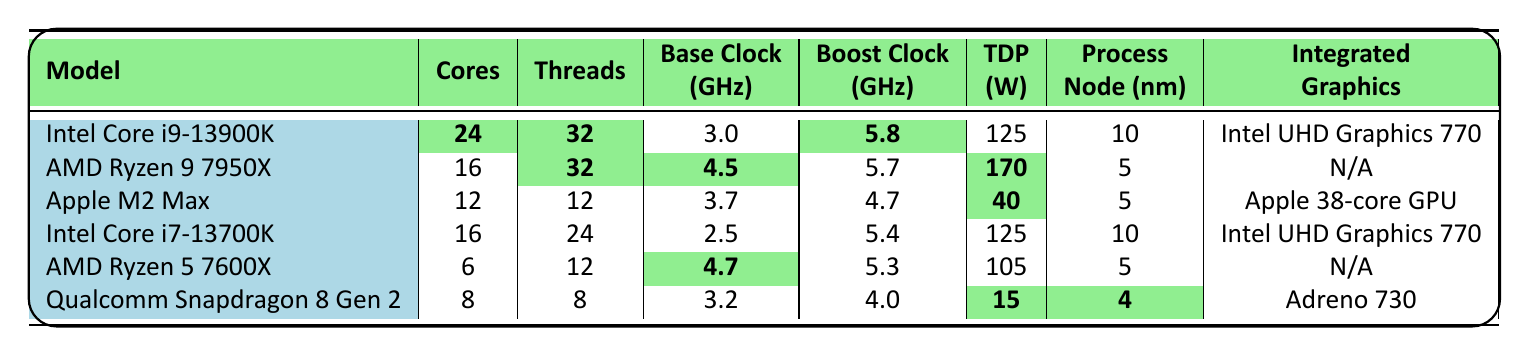What is the TDP of the AMD Ryzen 9 7950X? The TDP of the AMD Ryzen 9 7950X is listed directly in the table as 170 watts.
Answer: 170 W Which CPU has the highest base clock speed? By comparing the base clock speeds in the table, the AMD Ryzen 5 7600X has the highest base clock speed at 4.7 GHz.
Answer: 4.7 GHz How many threads does the Intel Core i7-13700K have? The number of threads for the Intel Core i7-13700K is clearly stated in the table as 24.
Answer: 24 What is the difference in TDP between the Intel Core i9-13900K and the Qualcomm Snapdragon 8 Gen 2? The TDP of the Intel Core i9-13900K is 125 W, and the TDP of the Qualcomm Snapdragon 8 Gen 2 is 15 W. The difference is 125 - 15 = 110 W.
Answer: 110 W Which CPU has the lowest number of cores? The table shows that the AMD Ryzen 5 7600X has the lowest number of cores, which is 6.
Answer: 6 What is the average base clock speed of the CPUs listed in the table? The base clock speeds are 3.0, 4.5, 3.7, 2.5, 4.7, and 3.2 GHz. Adding these gives a total of 21.6 GHz, and dividing by 6 (the number of CPUs) yields an average of 3.6 GHz.
Answer: 3.6 GHz True or False: The Apple M2 Max has more threads than the AMD Ryzen 5 7600X. The table indicates that the Apple M2 Max has 12 threads, while the AMD Ryzen 5 7600X has 12 threads as well. Therefore, the statement is false as they have equal threads.
Answer: False Which CPU has the highest boost clock speed? According to the table, the Intel Core i9-13900K has the highest boost clock speed at 5.8 GHz.
Answer: 5.8 GHz If you combine the cores of Intel Core i9-13900K and AMD Ryzen 9 7950X, how many cores will you have in total? The Intel Core i9-13900K has 24 cores and the AMD Ryzen 9 7950X has 16 cores. Adding these values together gives 24 + 16 = 40 cores in total.
Answer: 40 What is the process node size of the Qualcomm Snapdragon 8 Gen 2? The process node size for the Qualcomm Snapdragon 8 Gen 2 is mentioned in the table as 4 nm.
Answer: 4 nm Which CPU uses integrated graphics? From the table, both Intel CPUs (i9-13900K and i7-13700K) use integrated graphics, specifically the Intel UHD Graphics 770.
Answer: Intel Core i9-13900K and Intel Core i7-13700K 